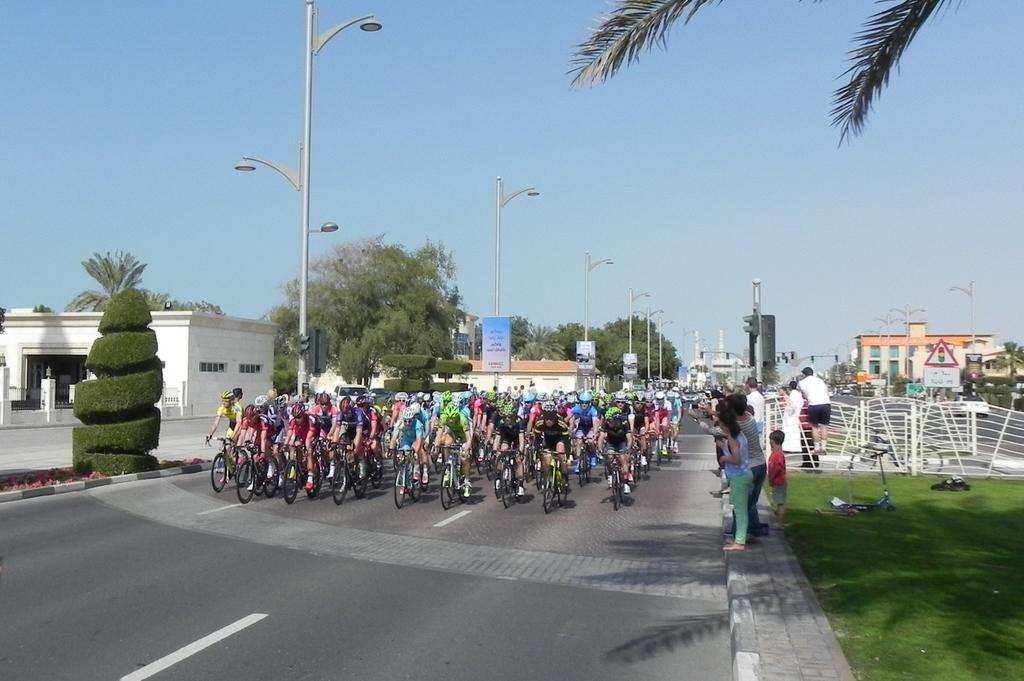What are the persons in the image doing? There are persons riding bicycles in the image. Are there any other activities being performed by the persons in the image? Yes, there are persons standing in the image. What objects can be seen in the image besides the persons? There are poles and trees in the image. What is visible in the background of the image? The sky is visible in the image. What type of joke is being told by the horse in the image? There is no horse present in the image, so no joke can be told by a horse. Can you tell me how many basketballs are visible in the image? There are no basketballs present in the image. 